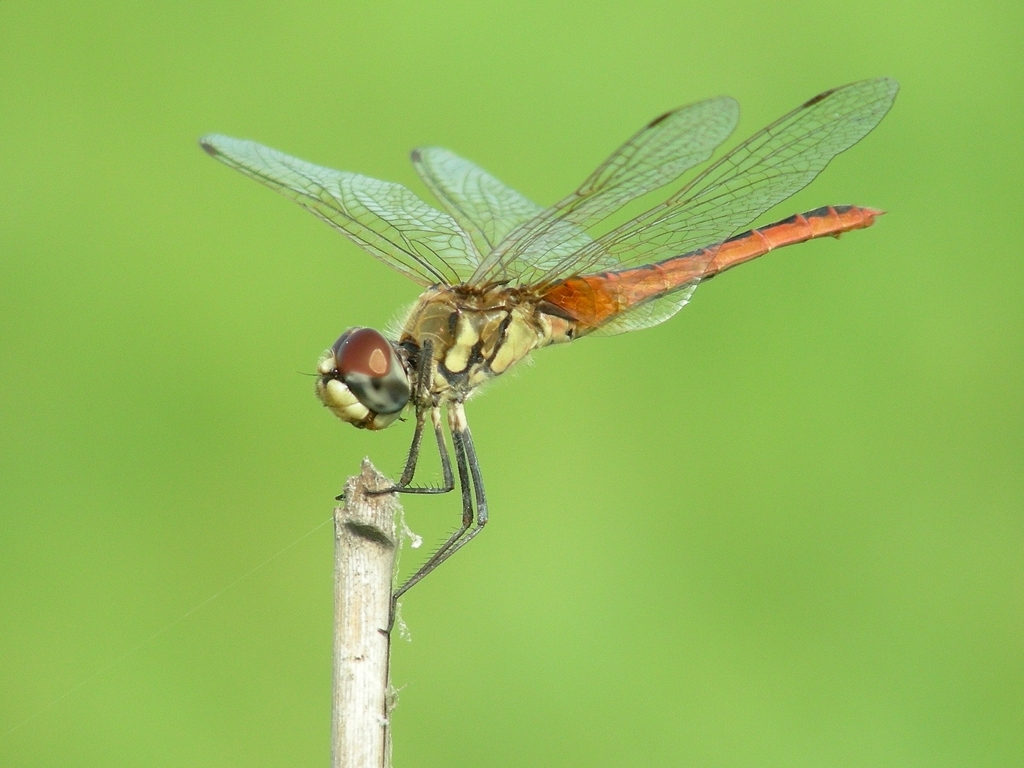Does this image hold any biological value? Indeed, the image holds significant biological value. It features a dragonfly, an insect which plays a vital role in the ecosystem both as a predator and as prey, offering insights into insect physiology and aerodynamics, biodiversity, and environmental health. 